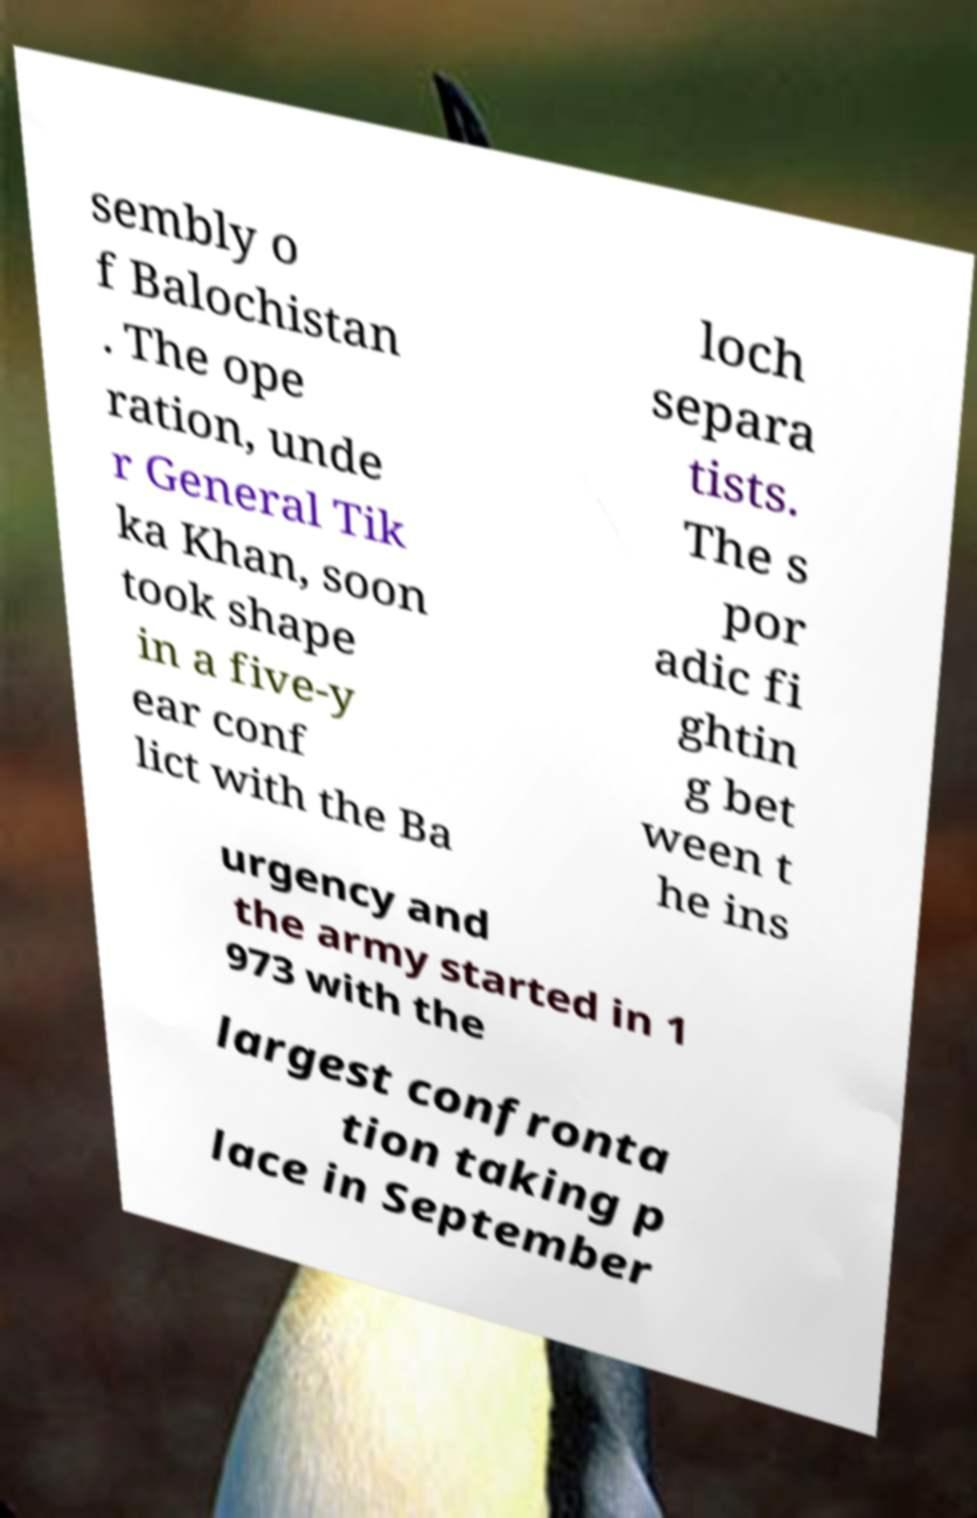There's text embedded in this image that I need extracted. Can you transcribe it verbatim? sembly o f Balochistan . The ope ration, unde r General Tik ka Khan, soon took shape in a five-y ear conf lict with the Ba loch separa tists. The s por adic fi ghtin g bet ween t he ins urgency and the army started in 1 973 with the largest confronta tion taking p lace in September 